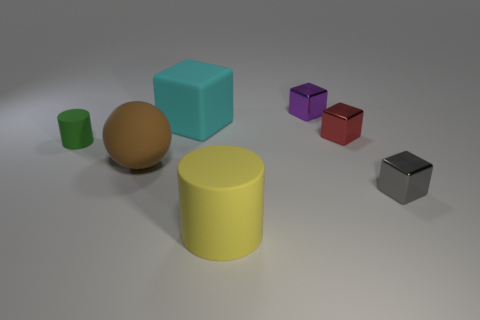Subtract all green blocks. Subtract all green cylinders. How many blocks are left? 4 Add 1 rubber blocks. How many objects exist? 8 Subtract all blocks. How many objects are left? 3 Add 1 small gray rubber things. How many small gray rubber things exist? 1 Subtract 1 green cylinders. How many objects are left? 6 Subtract all green things. Subtract all tiny gray objects. How many objects are left? 5 Add 4 cyan objects. How many cyan objects are left? 5 